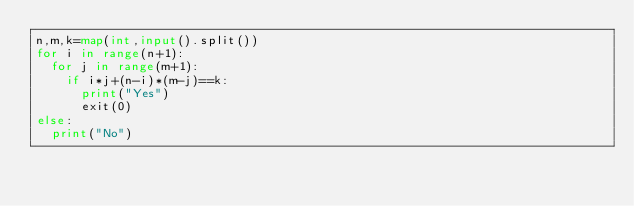Convert code to text. <code><loc_0><loc_0><loc_500><loc_500><_Python_>n,m,k=map(int,input().split())
for i in range(n+1):
  for j in range(m+1):
    if i*j+(n-i)*(m-j)==k:
      print("Yes")
      exit(0)
else:
  print("No")</code> 